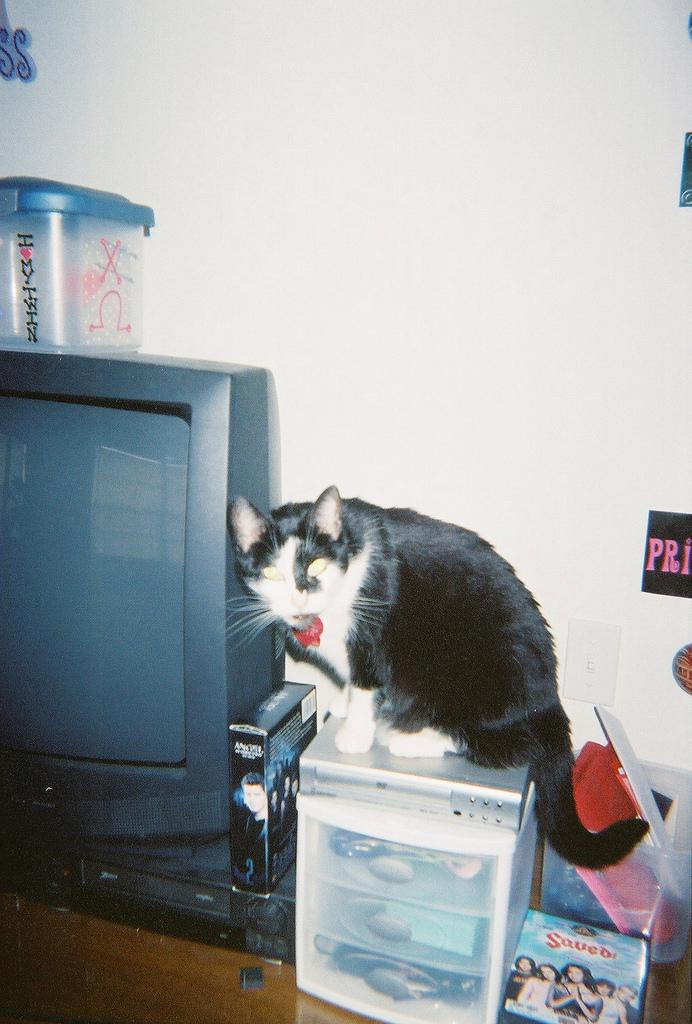Question: what does the upper box say?
Choices:
A. Shop here.
B. How long.
C. Line starts here.
D. I love my twin.
Answer with the letter. Answer: D Question: who is in this picture?
Choices:
A. A woman.
B. A boy.
C. A baby.
D. No one.
Answer with the letter. Answer: D Question: what type of animal is this?
Choices:
A. A dog.
B. A cat.
C. A rabbit.
D. A bird.
Answer with the letter. Answer: B Question: what is the cat sitting on?
Choices:
A. Table.
B. Windowsill.
C. Storage containers.
D. Rug.
Answer with the letter. Answer: C Question: what does the storage container sit on?
Choices:
A. A television.
B. Box.
C. Table.
D. Chair.
Answer with the letter. Answer: A Question: what is the cat wearing?
Choices:
A. Hat.
B. A red tag.
C. Glasses.
D. Crown.
Answer with the letter. Answer: B Question: what color are the walls?
Choices:
A. Green.
B. White.
C. Blue.
D. Red.
Answer with the letter. Answer: B Question: what color tag does the cat have?
Choices:
A. Blue.
B. Purple.
C. Red.
D. Green.
Answer with the letter. Answer: C Question: what are on the wall?
Choices:
A. Posters.
B. Stickers.
C. Crayon markings.
D. Stripes.
Answer with the letter. Answer: B Question: where is the black sticker with pink writing?
Choices:
A. On the TV.
B. On the fridge.
C. On the folder.
D. On the wall.
Answer with the letter. Answer: D Question: where is the cat sitting?
Choices:
A. On a pillow.
B. In it's bed.
C. On a window sill.
D. On a box.
Answer with the letter. Answer: D Question: how many cats are in the picture?
Choices:
A. Two.
B. Ten.
C. One.
D. Six.
Answer with the letter. Answer: C 